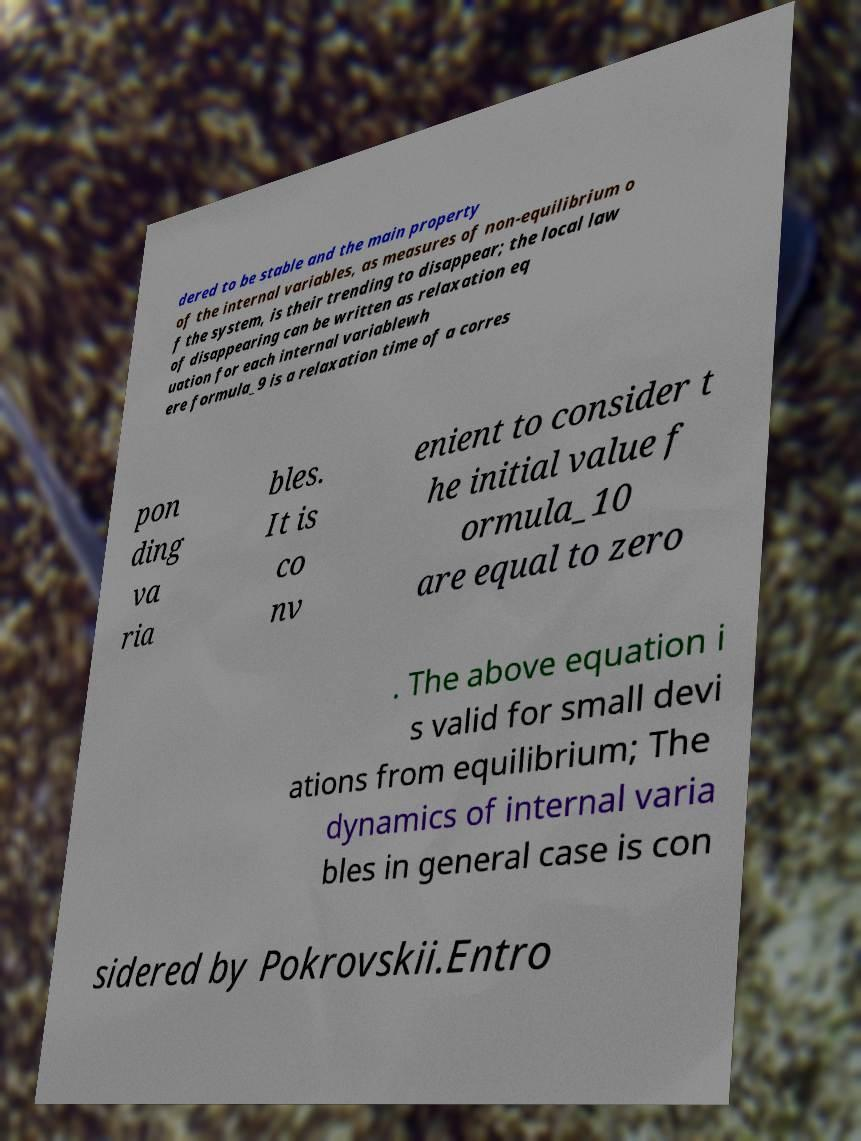There's text embedded in this image that I need extracted. Can you transcribe it verbatim? dered to be stable and the main property of the internal variables, as measures of non-equilibrium o f the system, is their trending to disappear; the local law of disappearing can be written as relaxation eq uation for each internal variablewh ere formula_9 is a relaxation time of a corres pon ding va ria bles. It is co nv enient to consider t he initial value f ormula_10 are equal to zero . The above equation i s valid for small devi ations from equilibrium; The dynamics of internal varia bles in general case is con sidered by Pokrovskii.Entro 